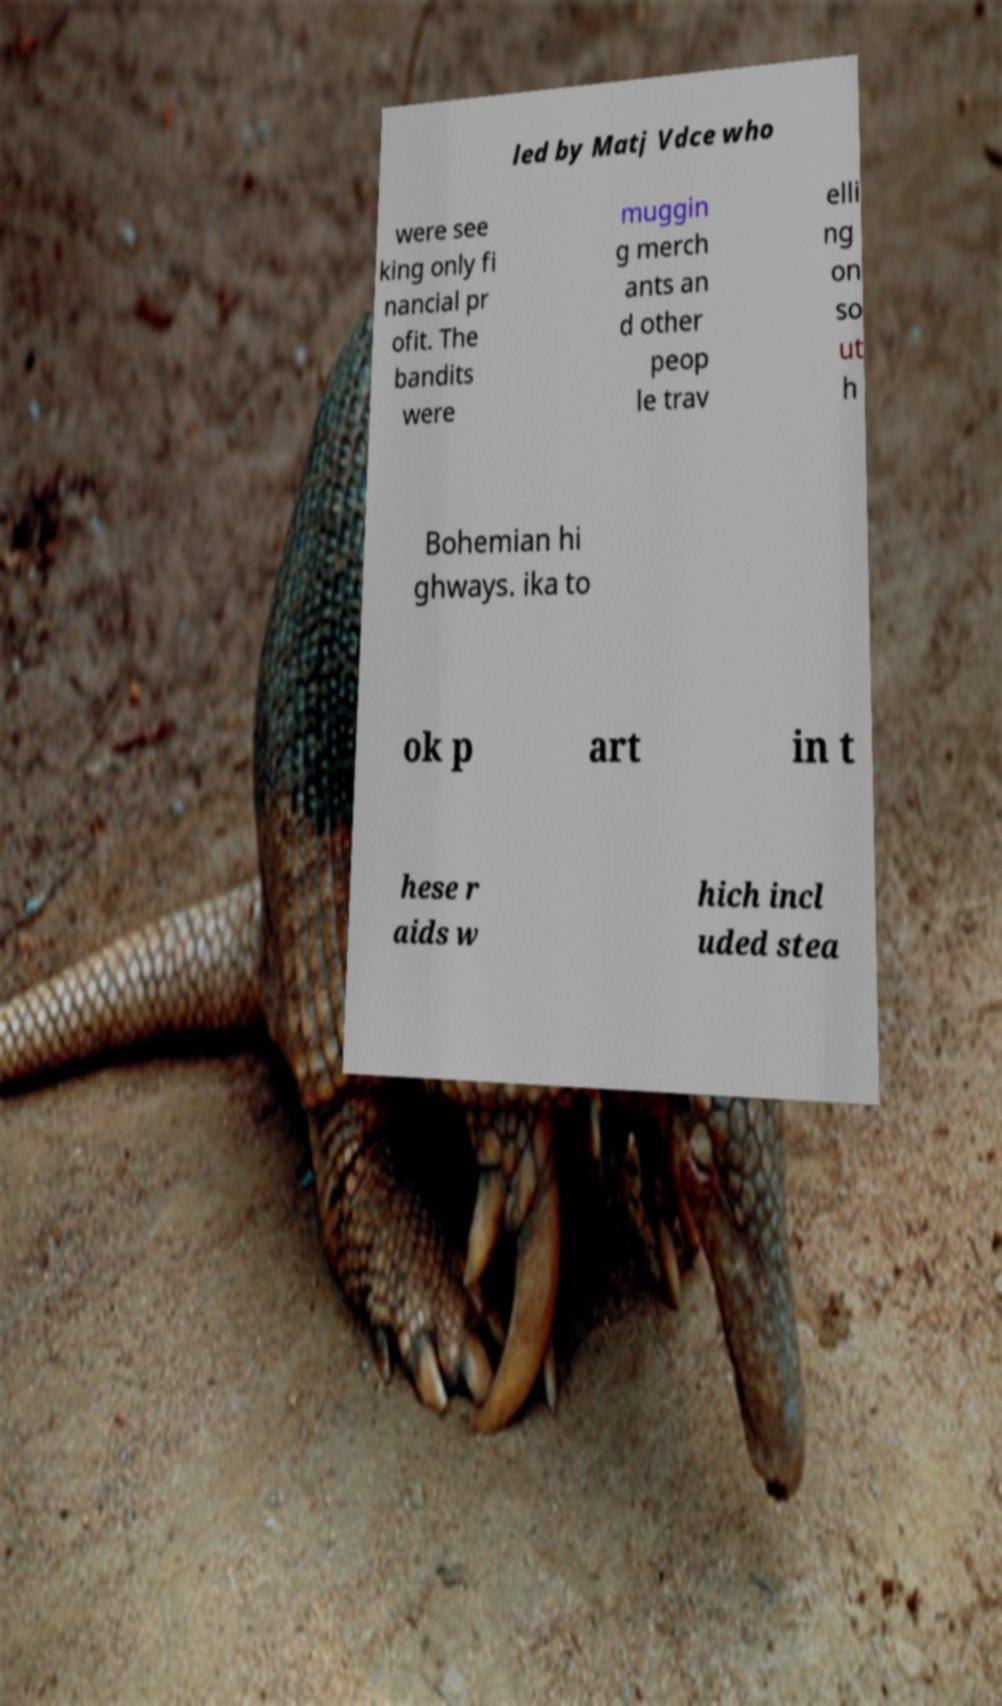Please read and relay the text visible in this image. What does it say? led by Matj Vdce who were see king only fi nancial pr ofit. The bandits were muggin g merch ants an d other peop le trav elli ng on so ut h Bohemian hi ghways. ika to ok p art in t hese r aids w hich incl uded stea 